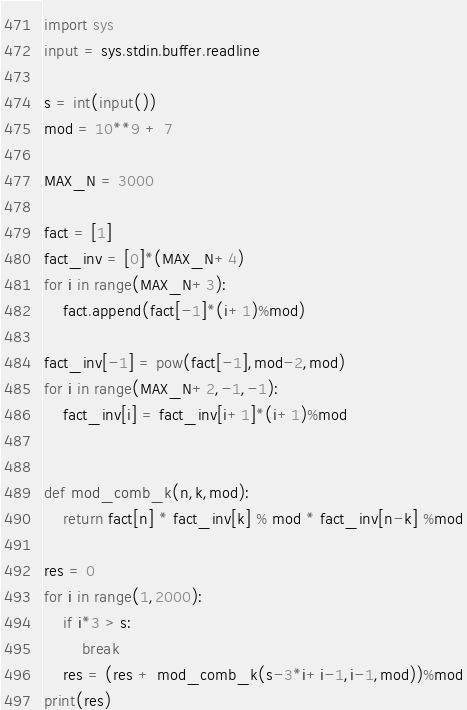Convert code to text. <code><loc_0><loc_0><loc_500><loc_500><_Python_>import sys
input = sys.stdin.buffer.readline

s = int(input())
mod = 10**9 + 7

MAX_N = 3000

fact = [1]
fact_inv = [0]*(MAX_N+4)
for i in range(MAX_N+3):
    fact.append(fact[-1]*(i+1)%mod)

fact_inv[-1] = pow(fact[-1],mod-2,mod)
for i in range(MAX_N+2,-1,-1):
    fact_inv[i] = fact_inv[i+1]*(i+1)%mod


def mod_comb_k(n,k,mod):
    return fact[n] * fact_inv[k] % mod * fact_inv[n-k] %mod

res = 0
for i in range(1,2000):
    if i*3 > s:
        break
    res = (res + mod_comb_k(s-3*i+i-1,i-1,mod))%mod
print(res)</code> 